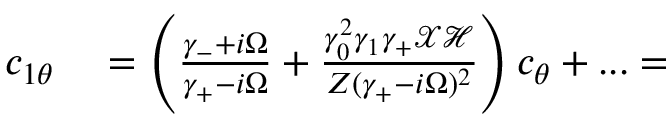Convert formula to latex. <formula><loc_0><loc_0><loc_500><loc_500>\begin{array} { r l } { c _ { 1 \theta } } & = \left ( \frac { \gamma _ { - } + i \Omega } { \gamma _ { + } - i \Omega } + \frac { \gamma _ { 0 } ^ { 2 } \gamma _ { 1 } \gamma _ { + } \mathcal { X } \mathcal { H } } { Z ( \gamma _ { + } - i \Omega ) ^ { 2 } } \right ) c _ { \theta } + \dots = } \end{array}</formula> 